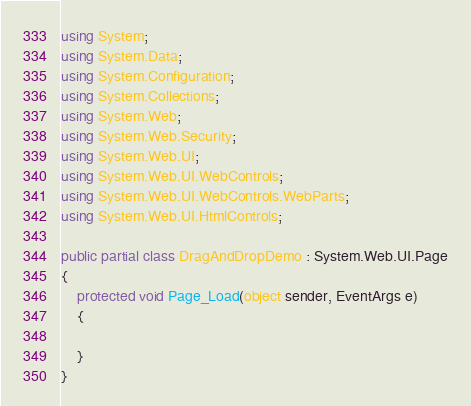Convert code to text. <code><loc_0><loc_0><loc_500><loc_500><_C#_>using System;
using System.Data;
using System.Configuration;
using System.Collections;
using System.Web;
using System.Web.Security;
using System.Web.UI;
using System.Web.UI.WebControls;
using System.Web.UI.WebControls.WebParts;
using System.Web.UI.HtmlControls;

public partial class DragAndDropDemo : System.Web.UI.Page
{
    protected void Page_Load(object sender, EventArgs e)
    {

    }
}
</code> 